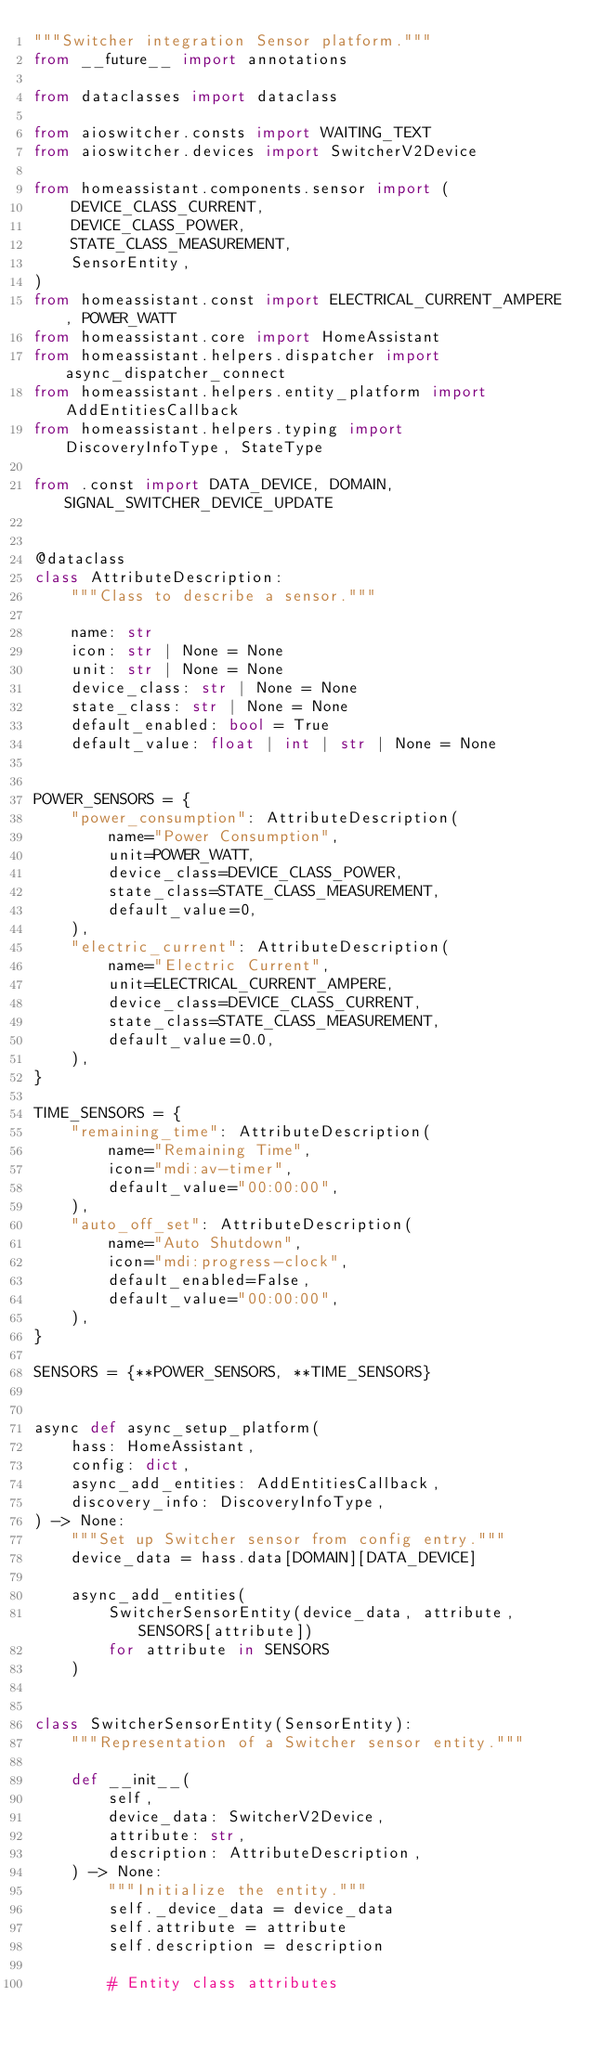<code> <loc_0><loc_0><loc_500><loc_500><_Python_>"""Switcher integration Sensor platform."""
from __future__ import annotations

from dataclasses import dataclass

from aioswitcher.consts import WAITING_TEXT
from aioswitcher.devices import SwitcherV2Device

from homeassistant.components.sensor import (
    DEVICE_CLASS_CURRENT,
    DEVICE_CLASS_POWER,
    STATE_CLASS_MEASUREMENT,
    SensorEntity,
)
from homeassistant.const import ELECTRICAL_CURRENT_AMPERE, POWER_WATT
from homeassistant.core import HomeAssistant
from homeassistant.helpers.dispatcher import async_dispatcher_connect
from homeassistant.helpers.entity_platform import AddEntitiesCallback
from homeassistant.helpers.typing import DiscoveryInfoType, StateType

from .const import DATA_DEVICE, DOMAIN, SIGNAL_SWITCHER_DEVICE_UPDATE


@dataclass
class AttributeDescription:
    """Class to describe a sensor."""

    name: str
    icon: str | None = None
    unit: str | None = None
    device_class: str | None = None
    state_class: str | None = None
    default_enabled: bool = True
    default_value: float | int | str | None = None


POWER_SENSORS = {
    "power_consumption": AttributeDescription(
        name="Power Consumption",
        unit=POWER_WATT,
        device_class=DEVICE_CLASS_POWER,
        state_class=STATE_CLASS_MEASUREMENT,
        default_value=0,
    ),
    "electric_current": AttributeDescription(
        name="Electric Current",
        unit=ELECTRICAL_CURRENT_AMPERE,
        device_class=DEVICE_CLASS_CURRENT,
        state_class=STATE_CLASS_MEASUREMENT,
        default_value=0.0,
    ),
}

TIME_SENSORS = {
    "remaining_time": AttributeDescription(
        name="Remaining Time",
        icon="mdi:av-timer",
        default_value="00:00:00",
    ),
    "auto_off_set": AttributeDescription(
        name="Auto Shutdown",
        icon="mdi:progress-clock",
        default_enabled=False,
        default_value="00:00:00",
    ),
}

SENSORS = {**POWER_SENSORS, **TIME_SENSORS}


async def async_setup_platform(
    hass: HomeAssistant,
    config: dict,
    async_add_entities: AddEntitiesCallback,
    discovery_info: DiscoveryInfoType,
) -> None:
    """Set up Switcher sensor from config entry."""
    device_data = hass.data[DOMAIN][DATA_DEVICE]

    async_add_entities(
        SwitcherSensorEntity(device_data, attribute, SENSORS[attribute])
        for attribute in SENSORS
    )


class SwitcherSensorEntity(SensorEntity):
    """Representation of a Switcher sensor entity."""

    def __init__(
        self,
        device_data: SwitcherV2Device,
        attribute: str,
        description: AttributeDescription,
    ) -> None:
        """Initialize the entity."""
        self._device_data = device_data
        self.attribute = attribute
        self.description = description

        # Entity class attributes</code> 